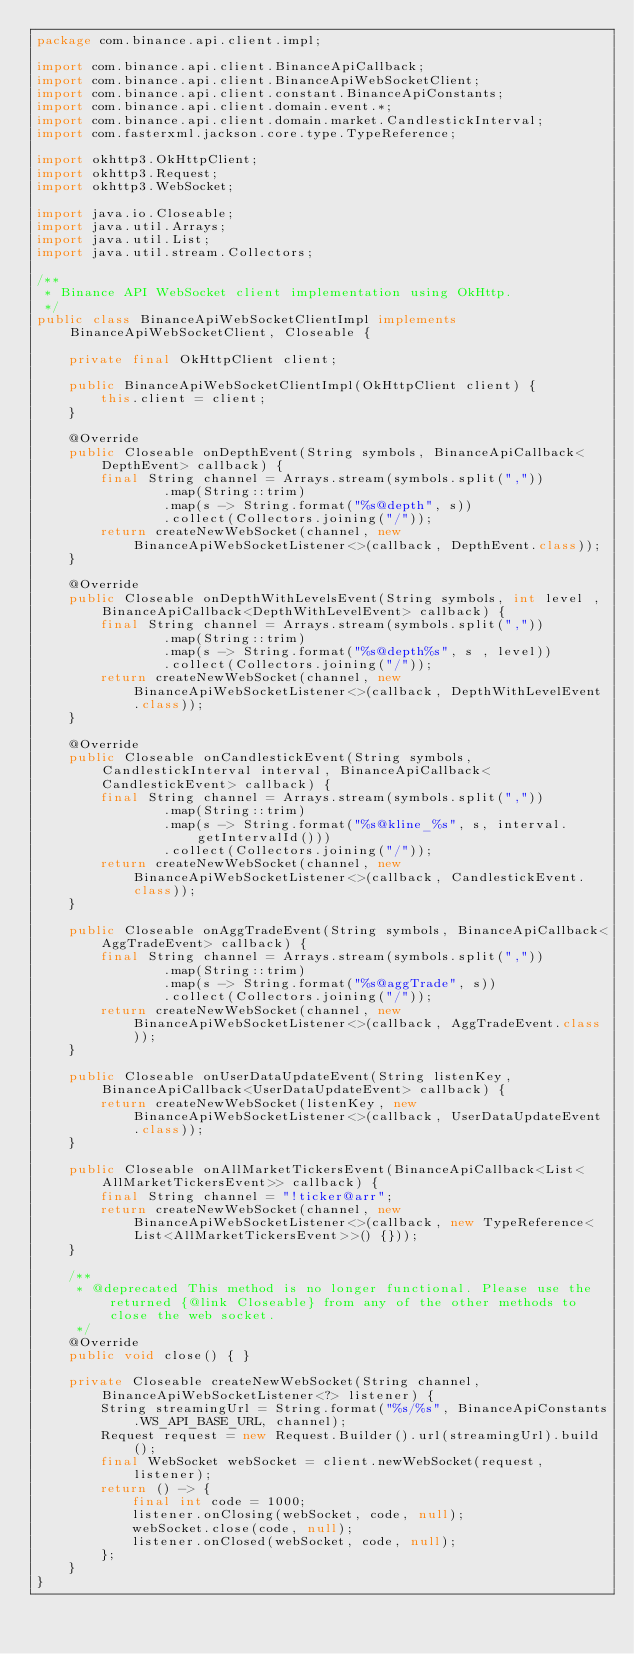Convert code to text. <code><loc_0><loc_0><loc_500><loc_500><_Java_>package com.binance.api.client.impl;

import com.binance.api.client.BinanceApiCallback;
import com.binance.api.client.BinanceApiWebSocketClient;
import com.binance.api.client.constant.BinanceApiConstants;
import com.binance.api.client.domain.event.*;
import com.binance.api.client.domain.market.CandlestickInterval;
import com.fasterxml.jackson.core.type.TypeReference;

import okhttp3.OkHttpClient;
import okhttp3.Request;
import okhttp3.WebSocket;

import java.io.Closeable;
import java.util.Arrays;
import java.util.List;
import java.util.stream.Collectors;

/**
 * Binance API WebSocket client implementation using OkHttp.
 */
public class BinanceApiWebSocketClientImpl implements BinanceApiWebSocketClient, Closeable {

    private final OkHttpClient client;

    public BinanceApiWebSocketClientImpl(OkHttpClient client) {
        this.client = client;
    }

    @Override
    public Closeable onDepthEvent(String symbols, BinanceApiCallback<DepthEvent> callback) {
        final String channel = Arrays.stream(symbols.split(","))
                .map(String::trim)
                .map(s -> String.format("%s@depth", s))
                .collect(Collectors.joining("/"));
        return createNewWebSocket(channel, new BinanceApiWebSocketListener<>(callback, DepthEvent.class));
    }

    @Override
    public Closeable onDepthWithLevelsEvent(String symbols, int level , BinanceApiCallback<DepthWithLevelEvent> callback) {
        final String channel = Arrays.stream(symbols.split(","))
                .map(String::trim)
                .map(s -> String.format("%s@depth%s", s , level))
                .collect(Collectors.joining("/"));
        return createNewWebSocket(channel, new BinanceApiWebSocketListener<>(callback, DepthWithLevelEvent.class));
    }

    @Override
    public Closeable onCandlestickEvent(String symbols, CandlestickInterval interval, BinanceApiCallback<CandlestickEvent> callback) {
        final String channel = Arrays.stream(symbols.split(","))
                .map(String::trim)
                .map(s -> String.format("%s@kline_%s", s, interval.getIntervalId()))
                .collect(Collectors.joining("/"));
        return createNewWebSocket(channel, new BinanceApiWebSocketListener<>(callback, CandlestickEvent.class));
    }

    public Closeable onAggTradeEvent(String symbols, BinanceApiCallback<AggTradeEvent> callback) {
        final String channel = Arrays.stream(symbols.split(","))
                .map(String::trim)
                .map(s -> String.format("%s@aggTrade", s))
                .collect(Collectors.joining("/"));
        return createNewWebSocket(channel, new BinanceApiWebSocketListener<>(callback, AggTradeEvent.class));
    }

    public Closeable onUserDataUpdateEvent(String listenKey, BinanceApiCallback<UserDataUpdateEvent> callback) {
        return createNewWebSocket(listenKey, new BinanceApiWebSocketListener<>(callback, UserDataUpdateEvent.class));
    }

    public Closeable onAllMarketTickersEvent(BinanceApiCallback<List<AllMarketTickersEvent>> callback) {
        final String channel = "!ticker@arr";
        return createNewWebSocket(channel, new BinanceApiWebSocketListener<>(callback, new TypeReference<List<AllMarketTickersEvent>>() {}));
    }

    /**
     * @deprecated This method is no longer functional. Please use the returned {@link Closeable} from any of the other methods to close the web socket.
     */
    @Override
    public void close() { }

    private Closeable createNewWebSocket(String channel, BinanceApiWebSocketListener<?> listener) {
        String streamingUrl = String.format("%s/%s", BinanceApiConstants.WS_API_BASE_URL, channel);
        Request request = new Request.Builder().url(streamingUrl).build();
        final WebSocket webSocket = client.newWebSocket(request, listener);
        return () -> {
            final int code = 1000;
            listener.onClosing(webSocket, code, null);
            webSocket.close(code, null);
            listener.onClosed(webSocket, code, null);
        };
    }
}
</code> 